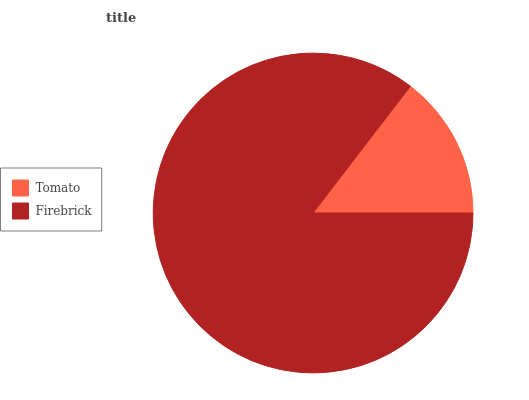Is Tomato the minimum?
Answer yes or no. Yes. Is Firebrick the maximum?
Answer yes or no. Yes. Is Firebrick the minimum?
Answer yes or no. No. Is Firebrick greater than Tomato?
Answer yes or no. Yes. Is Tomato less than Firebrick?
Answer yes or no. Yes. Is Tomato greater than Firebrick?
Answer yes or no. No. Is Firebrick less than Tomato?
Answer yes or no. No. Is Firebrick the high median?
Answer yes or no. Yes. Is Tomato the low median?
Answer yes or no. Yes. Is Tomato the high median?
Answer yes or no. No. Is Firebrick the low median?
Answer yes or no. No. 